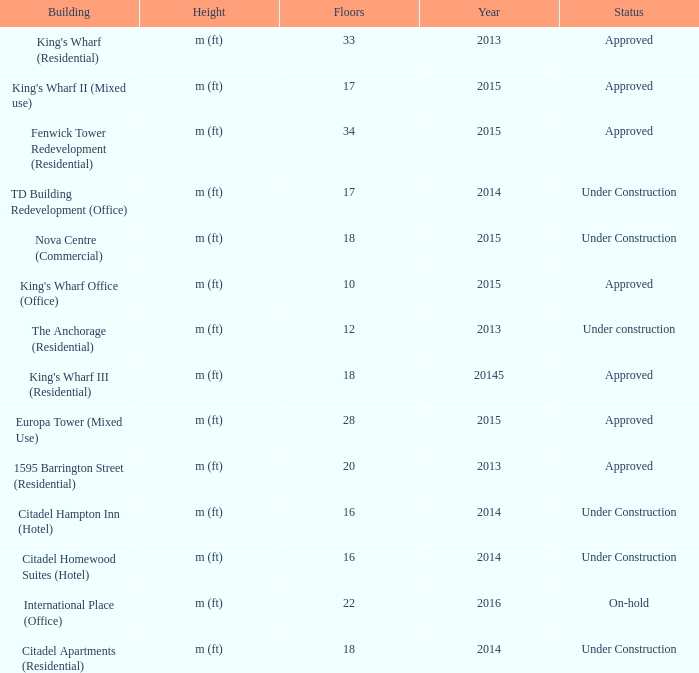What is the status of the building with more than 28 floor and a year of 2013? Approved. 